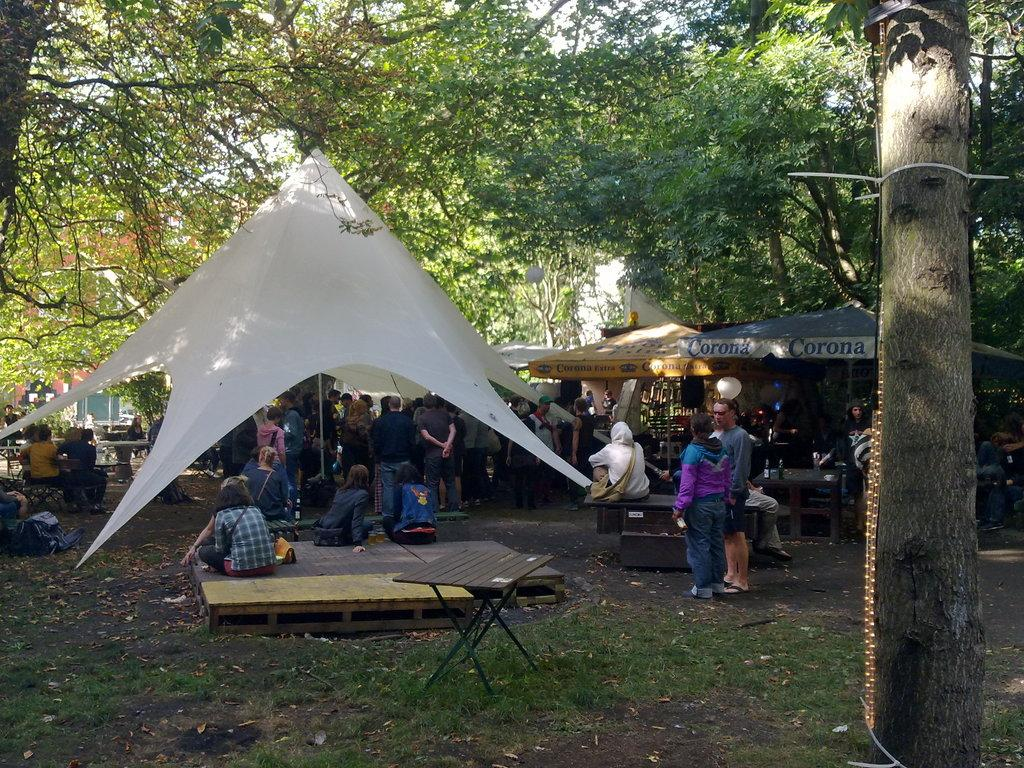What are the people in the image doing? The people in the image are standing and sitting. Where are the people located in the image? The people are under a tent. What can be seen in the background of the image? There are trees in the background of the image. What type of pump is visible in the image? There is no pump present in the image. Can you describe the stem of the tree in the image? There is no stem visible in the image, as the trees are in the background and not the main focus. 